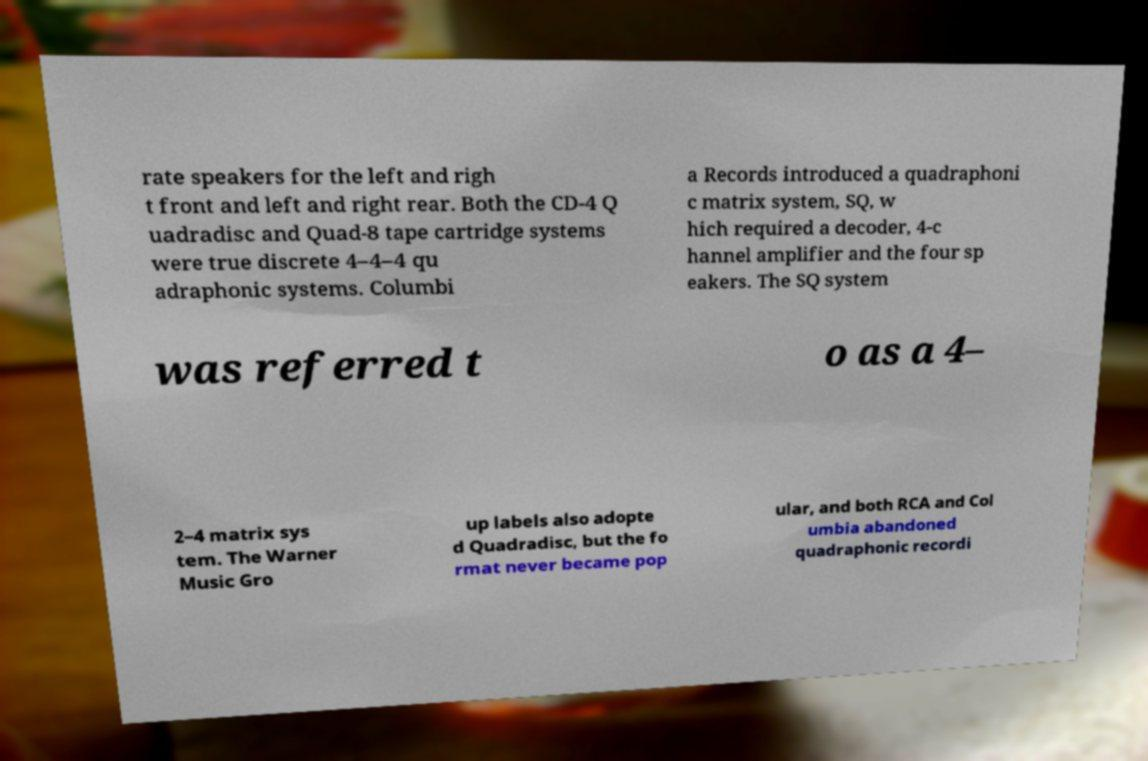Please identify and transcribe the text found in this image. rate speakers for the left and righ t front and left and right rear. Both the CD-4 Q uadradisc and Quad-8 tape cartridge systems were true discrete 4–4–4 qu adraphonic systems. Columbi a Records introduced a quadraphoni c matrix system, SQ, w hich required a decoder, 4-c hannel amplifier and the four sp eakers. The SQ system was referred t o as a 4– 2–4 matrix sys tem. The Warner Music Gro up labels also adopte d Quadradisc, but the fo rmat never became pop ular, and both RCA and Col umbia abandoned quadraphonic recordi 